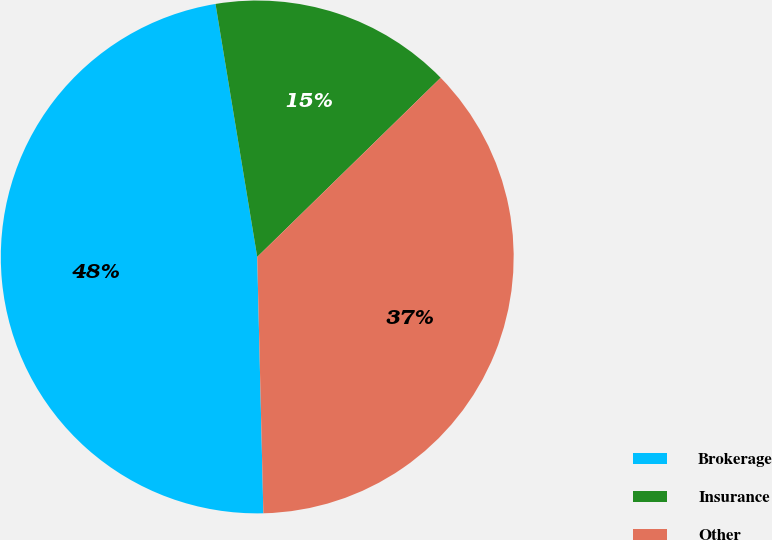Convert chart. <chart><loc_0><loc_0><loc_500><loc_500><pie_chart><fcel>Brokerage<fcel>Insurance<fcel>Other<nl><fcel>47.78%<fcel>15.29%<fcel>36.93%<nl></chart> 